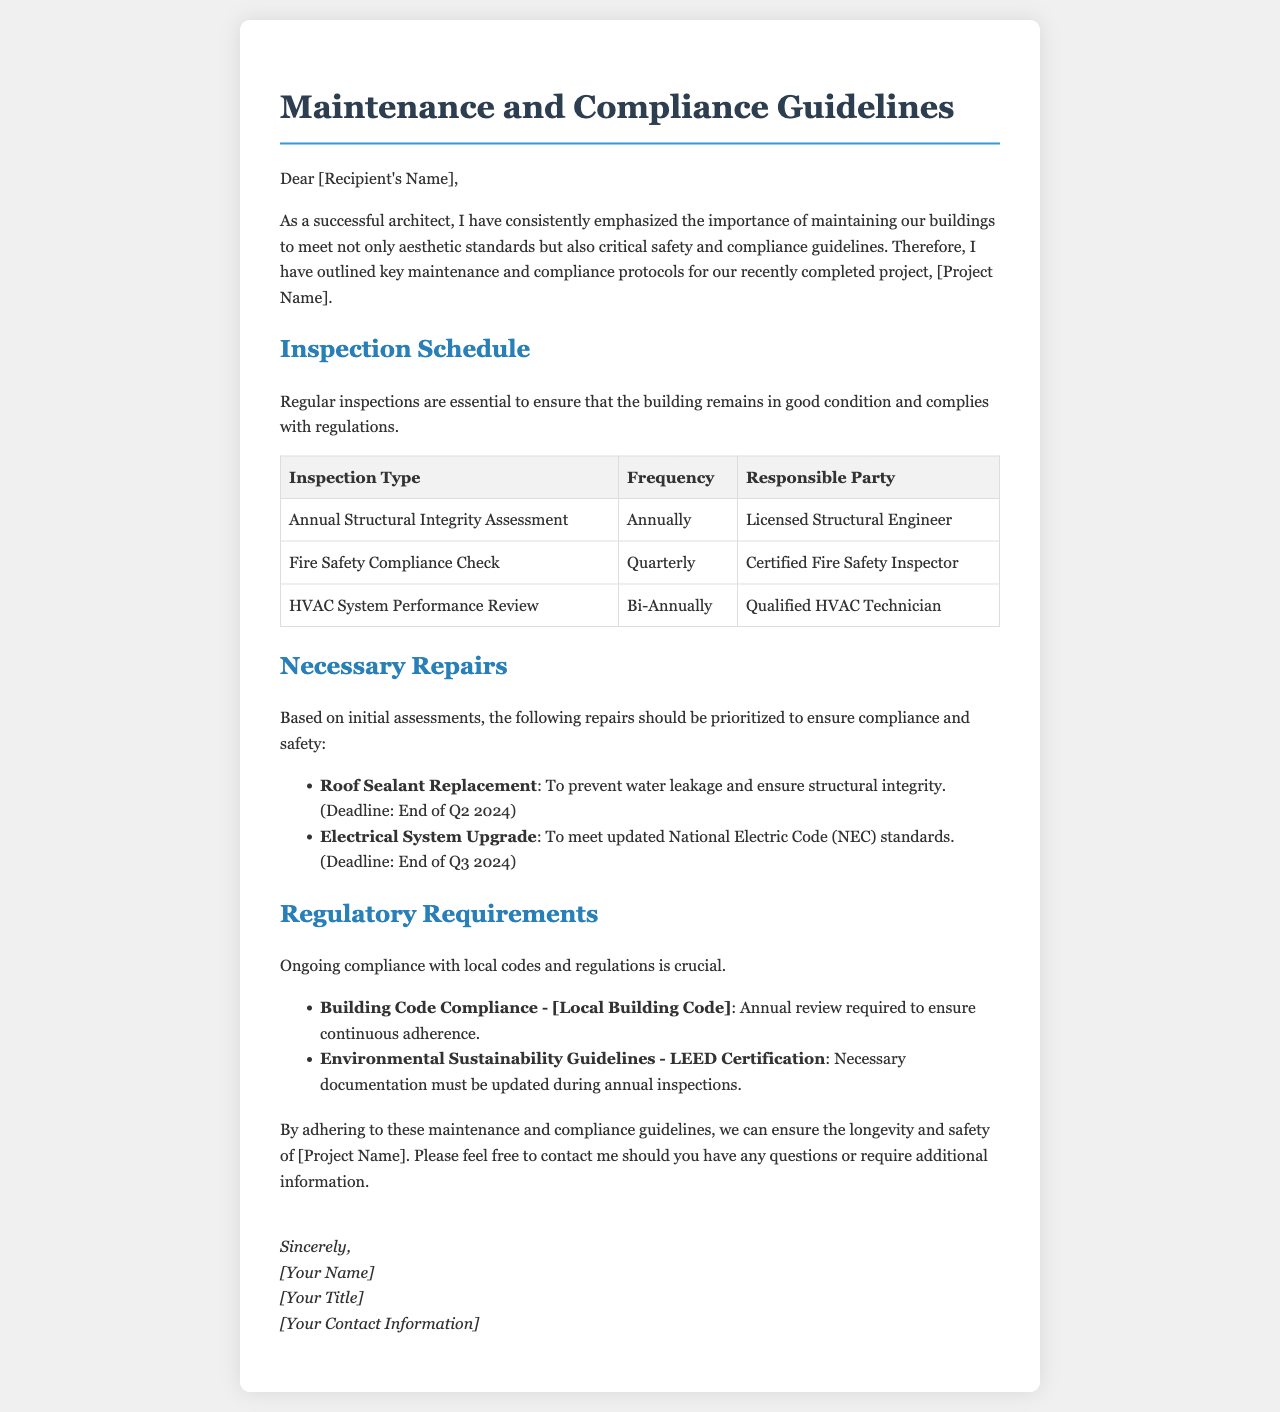What is the inspection frequency for the Fire Safety Compliance Check? The document states that the Fire Safety Compliance Check is to be performed quarterly.
Answer: Quarterly Who is responsible for the Annual Structural Integrity Assessment? The responsible party for the Annual Structural Integrity Assessment, as mentioned in the document, is a Licensed Structural Engineer.
Answer: Licensed Structural Engineer What is the deadline for the Roof Sealant Replacement? The document specifies that the deadline for the Roof Sealant Replacement is the end of Q2 2024.
Answer: End of Q2 2024 Which code requires an annual review for compliance? The document indicates that the Building Code Compliance, specifically [Local Building Code], requires an annual review for compliance.
Answer: [Local Building Code] How often should the HVAC System Performance Review be conducted? According to the document, the HVAC System Performance Review should be conducted bi-annually.
Answer: Bi-Annually What is the necessary certification for Environmental Sustainability Guidelines? The document references LEED Certification as the necessary certification for Environmental Sustainability Guidelines.
Answer: LEED Certification What is the main goal of these guidelines outlined in the document? The main goal of the guidelines is to ensure the longevity and safety of the recently completed building project.
Answer: Longevity and safety What type of letter is this document? The structure and content indicate that this is a formal maintenance and compliance guidelines letter.
Answer: Formal letter 